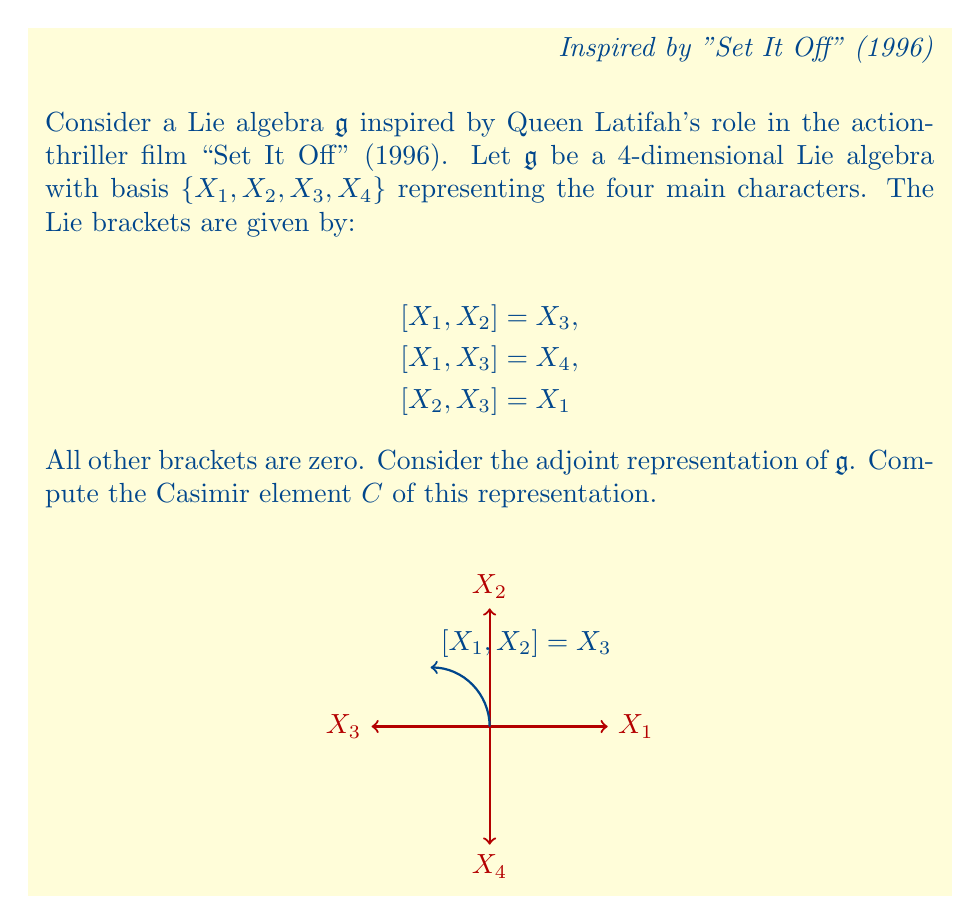What is the answer to this math problem? To compute the Casimir element, we follow these steps:

1) First, we need to find the Killing form $B(X,Y) = \text{tr}(\text{ad}_X \circ \text{ad}_Y)$ for all basis elements.

2) Let's compute the adjoint matrices:

   $\text{ad}_{X_1} = \begin{pmatrix} 0 & 0 & 0 & 0 \\ 0 & 0 & -1 & 0 \\ 0 & 1 & 0 & -1 \\ 0 & 0 & 0 & 0 \end{pmatrix}$

   $\text{ad}_{X_2} = \begin{pmatrix} 0 & 0 & 1 & 0 \\ 0 & 0 & 0 & 0 \\ -1 & 0 & 0 & 0 \\ 0 & 0 & 0 & 0 \end{pmatrix}$

   $\text{ad}_{X_3} = \begin{pmatrix} 0 & -1 & 0 & 0 \\ 1 & 0 & 0 & 0 \\ 0 & 0 & 0 & 0 \\ 0 & 0 & 0 & 0 \end{pmatrix}$

   $\text{ad}_{X_4} = \begin{pmatrix} 0 & 0 & 0 & 0 \\ 0 & 0 & 0 & 0 \\ 0 & 0 & 0 & 0 \\ 0 & 0 & 0 & 0 \end{pmatrix}$

3) Now, we compute the Killing form:

   $B(X_1,X_1) = \text{tr}(\text{ad}_{X_1} \circ \text{ad}_{X_1}) = 0$
   $B(X_2,X_2) = \text{tr}(\text{ad}_{X_2} \circ \text{ad}_{X_2}) = -1$
   $B(X_3,X_3) = \text{tr}(\text{ad}_{X_3} \circ \text{ad}_{X_3}) = -2$
   $B(X_4,X_4) = \text{tr}(\text{ad}_{X_4} \circ \text{ad}_{X_4}) = 0$

   All other combinations are zero.

4) The inverse of the Killing form matrix is:

   $B^{-1} = \begin{pmatrix} 0 & 0 & 0 & 0 \\ 0 & -1 & 0 & 0 \\ 0 & 0 & -1/2 & 0 \\ 0 & 0 & 0 & 0 \end{pmatrix}$

5) The Casimir element is given by:

   $C = \sum_{i,j} B^{ij} X_i \otimes X_j$

   where $B^{ij}$ are the entries of $B^{-1}$.

6) Therefore, the Casimir element is:

   $C = -X_2 \otimes X_2 - \frac{1}{2}X_3 \otimes X_3$
Answer: $C = -X_2 \otimes X_2 - \frac{1}{2}X_3 \otimes X_3$ 